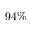<formula> <loc_0><loc_0><loc_500><loc_500>9 4 \%</formula> 